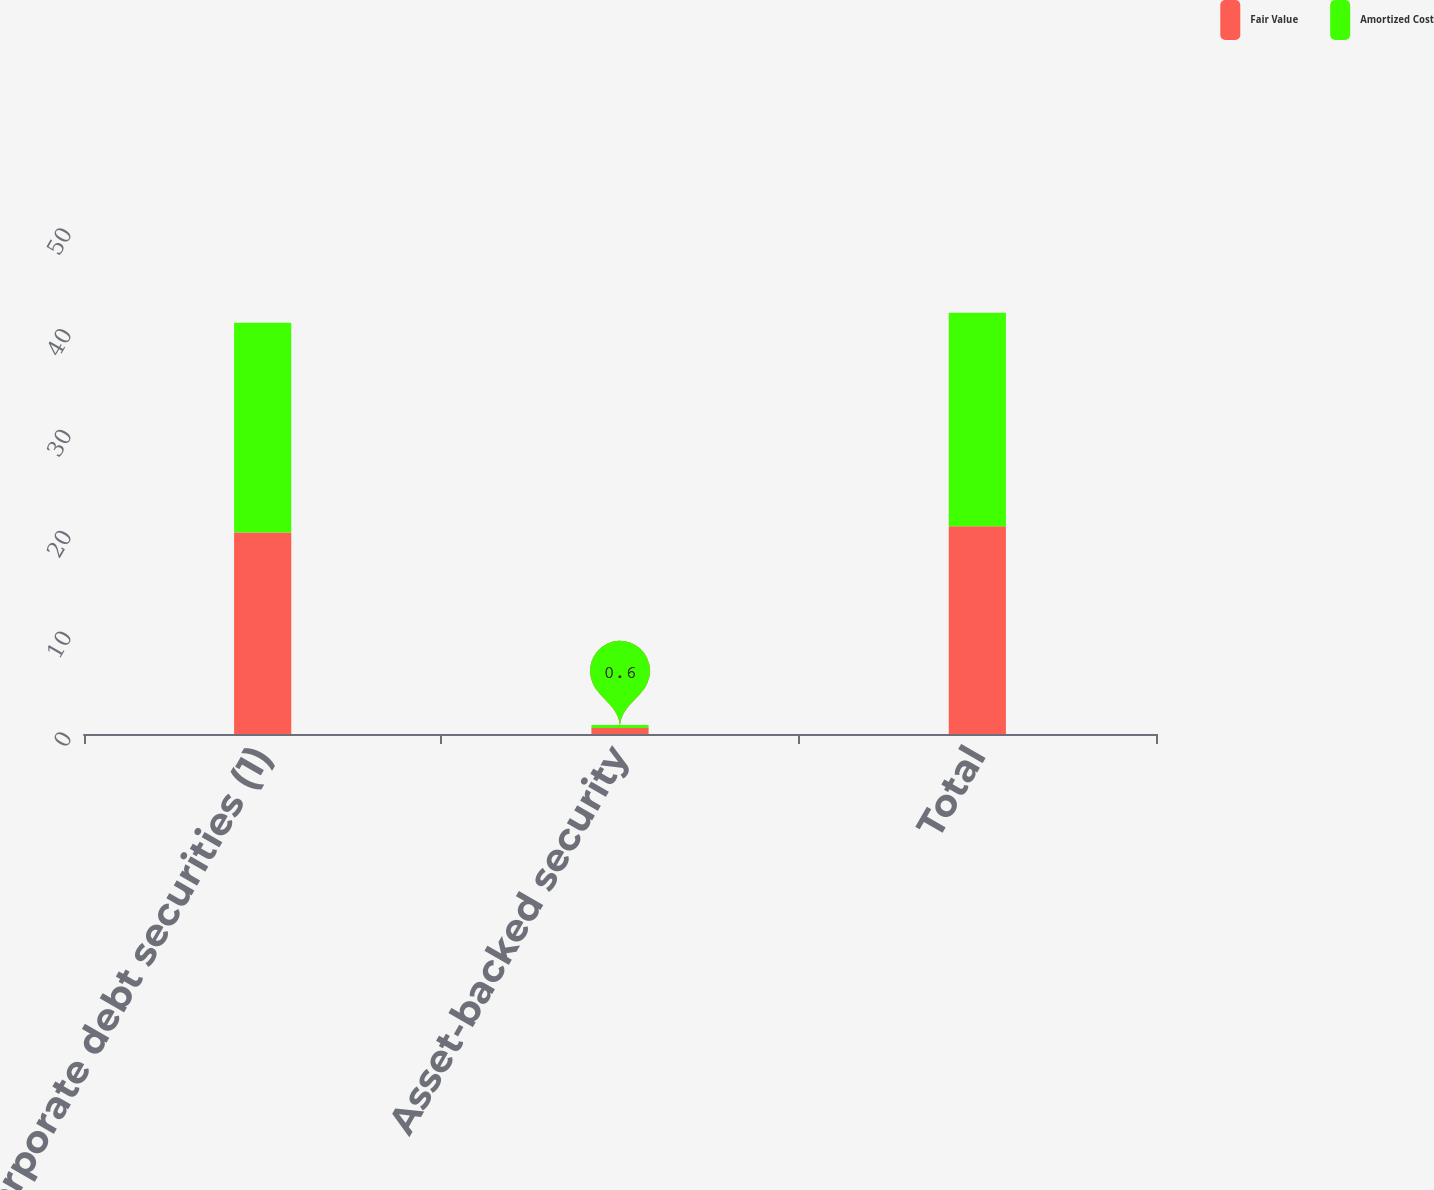Convert chart. <chart><loc_0><loc_0><loc_500><loc_500><stacked_bar_chart><ecel><fcel>Corporate debt securities (1)<fcel>Asset-backed security<fcel>Total<nl><fcel>Fair Value<fcel>20<fcel>0.6<fcel>20.6<nl><fcel>Amortized Cost<fcel>20.8<fcel>0.3<fcel>21.2<nl></chart> 